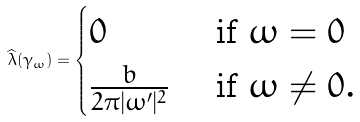Convert formula to latex. <formula><loc_0><loc_0><loc_500><loc_500>\widehat { \lambda } ( \gamma _ { \omega } ) = \begin{cases} 0 & \text { if } \omega = 0 \\ \frac { b } { 2 \pi | \omega ^ { \prime } | ^ { 2 } } & \text { if } \omega \neq 0 . \end{cases}</formula> 